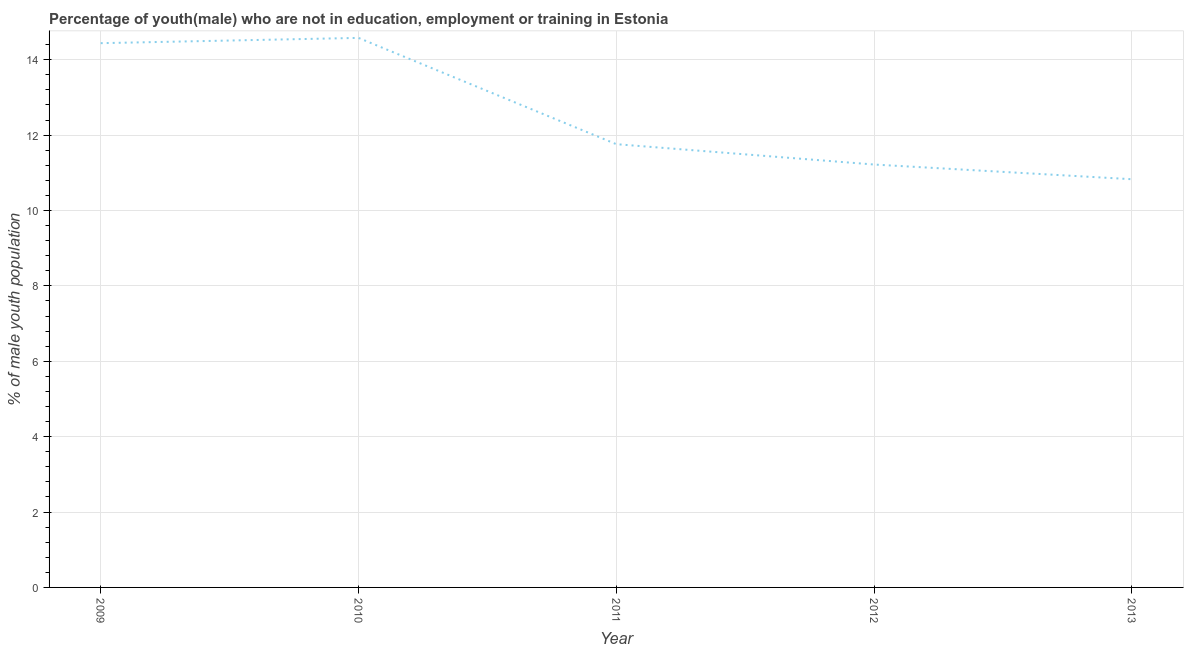What is the unemployed male youth population in 2009?
Offer a very short reply. 14.44. Across all years, what is the maximum unemployed male youth population?
Ensure brevity in your answer.  14.58. Across all years, what is the minimum unemployed male youth population?
Your response must be concise. 10.83. In which year was the unemployed male youth population minimum?
Provide a succinct answer. 2013. What is the sum of the unemployed male youth population?
Give a very brief answer. 62.83. What is the difference between the unemployed male youth population in 2009 and 2013?
Provide a short and direct response. 3.61. What is the average unemployed male youth population per year?
Offer a terse response. 12.57. What is the median unemployed male youth population?
Provide a short and direct response. 11.76. In how many years, is the unemployed male youth population greater than 14 %?
Offer a very short reply. 2. What is the ratio of the unemployed male youth population in 2011 to that in 2012?
Offer a terse response. 1.05. Is the unemployed male youth population in 2009 less than that in 2013?
Offer a very short reply. No. Is the difference between the unemployed male youth population in 2011 and 2013 greater than the difference between any two years?
Provide a succinct answer. No. What is the difference between the highest and the second highest unemployed male youth population?
Make the answer very short. 0.14. Is the sum of the unemployed male youth population in 2011 and 2012 greater than the maximum unemployed male youth population across all years?
Provide a short and direct response. Yes. What is the difference between the highest and the lowest unemployed male youth population?
Your answer should be compact. 3.75. In how many years, is the unemployed male youth population greater than the average unemployed male youth population taken over all years?
Offer a very short reply. 2. How many lines are there?
Offer a very short reply. 1. What is the difference between two consecutive major ticks on the Y-axis?
Ensure brevity in your answer.  2. Does the graph contain any zero values?
Keep it short and to the point. No. What is the title of the graph?
Your answer should be very brief. Percentage of youth(male) who are not in education, employment or training in Estonia. What is the label or title of the X-axis?
Keep it short and to the point. Year. What is the label or title of the Y-axis?
Ensure brevity in your answer.  % of male youth population. What is the % of male youth population of 2009?
Give a very brief answer. 14.44. What is the % of male youth population in 2010?
Provide a succinct answer. 14.58. What is the % of male youth population of 2011?
Give a very brief answer. 11.76. What is the % of male youth population in 2012?
Your answer should be very brief. 11.22. What is the % of male youth population of 2013?
Ensure brevity in your answer.  10.83. What is the difference between the % of male youth population in 2009 and 2010?
Your response must be concise. -0.14. What is the difference between the % of male youth population in 2009 and 2011?
Make the answer very short. 2.68. What is the difference between the % of male youth population in 2009 and 2012?
Your answer should be very brief. 3.22. What is the difference between the % of male youth population in 2009 and 2013?
Offer a terse response. 3.61. What is the difference between the % of male youth population in 2010 and 2011?
Make the answer very short. 2.82. What is the difference between the % of male youth population in 2010 and 2012?
Provide a short and direct response. 3.36. What is the difference between the % of male youth population in 2010 and 2013?
Give a very brief answer. 3.75. What is the difference between the % of male youth population in 2011 and 2012?
Offer a terse response. 0.54. What is the difference between the % of male youth population in 2011 and 2013?
Offer a very short reply. 0.93. What is the difference between the % of male youth population in 2012 and 2013?
Offer a terse response. 0.39. What is the ratio of the % of male youth population in 2009 to that in 2010?
Ensure brevity in your answer.  0.99. What is the ratio of the % of male youth population in 2009 to that in 2011?
Keep it short and to the point. 1.23. What is the ratio of the % of male youth population in 2009 to that in 2012?
Your answer should be very brief. 1.29. What is the ratio of the % of male youth population in 2009 to that in 2013?
Your answer should be very brief. 1.33. What is the ratio of the % of male youth population in 2010 to that in 2011?
Keep it short and to the point. 1.24. What is the ratio of the % of male youth population in 2010 to that in 2012?
Offer a terse response. 1.3. What is the ratio of the % of male youth population in 2010 to that in 2013?
Provide a short and direct response. 1.35. What is the ratio of the % of male youth population in 2011 to that in 2012?
Offer a terse response. 1.05. What is the ratio of the % of male youth population in 2011 to that in 2013?
Offer a very short reply. 1.09. What is the ratio of the % of male youth population in 2012 to that in 2013?
Offer a very short reply. 1.04. 